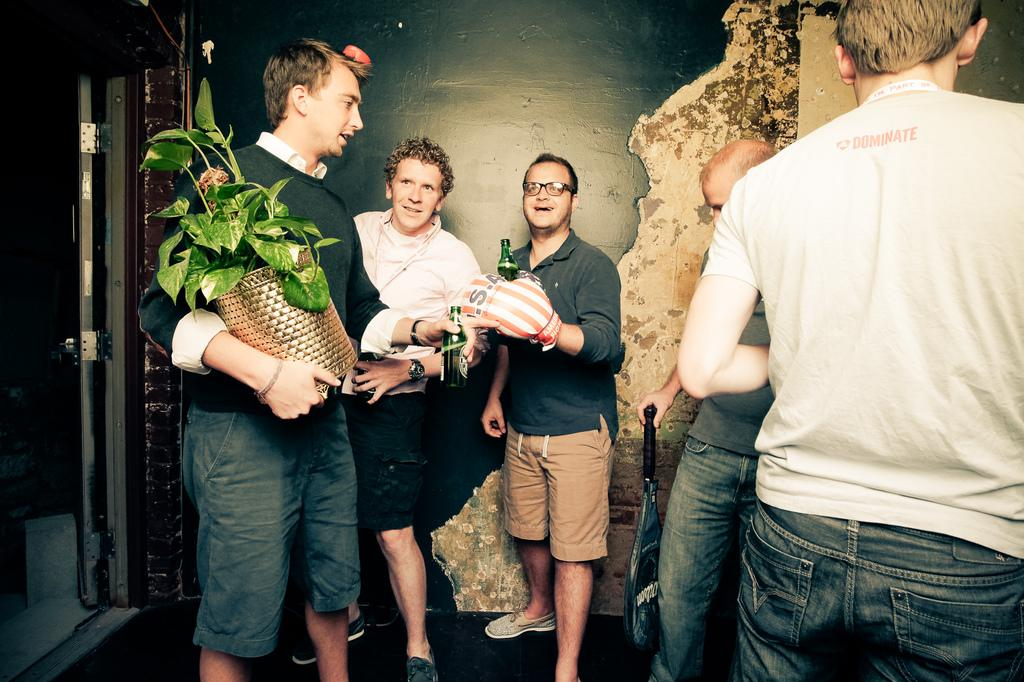How many people are in the image? There are people in the image. What are the men holding in the image? A man is holding a plant in a vase, another man is holding a bottle, and a third man is holding a racket. What can be seen in the background of the image? There is a wall in the background of the image. What type of cloth is being used to create friction in the image? There is no cloth or friction present in the image. How many hands are visible in the image? The number of hands visible in the image cannot be determined from the provided facts. 